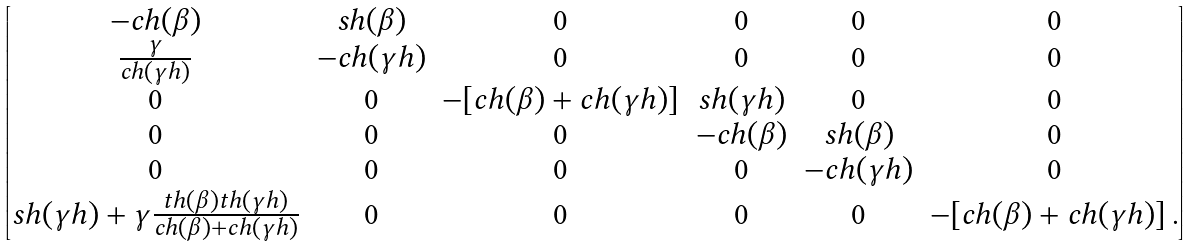<formula> <loc_0><loc_0><loc_500><loc_500>\begin{bmatrix} - c h ( \beta ) & s h ( \beta ) & 0 & 0 & 0 & 0 \\ \frac { \gamma } { c h ( \gamma h ) } & - c h ( \gamma h ) & 0 & 0 & 0 & 0 \\ 0 & 0 & - [ c h ( \beta ) + c h ( \gamma h ) ] & s h ( \gamma h ) & 0 & 0 \\ 0 & 0 & 0 & - c h ( \beta ) & s h ( \beta ) & 0 \\ 0 & 0 & 0 & 0 & - c h ( \gamma h ) & 0 \\ s h ( \gamma h ) + \gamma \frac { t h ( \beta ) t h ( \gamma h ) } { c h ( \beta ) + c h ( \gamma h ) } & 0 & 0 & 0 & 0 & - [ c h ( \beta ) + c h ( \gamma h ) ] \, . \end{bmatrix}</formula> 